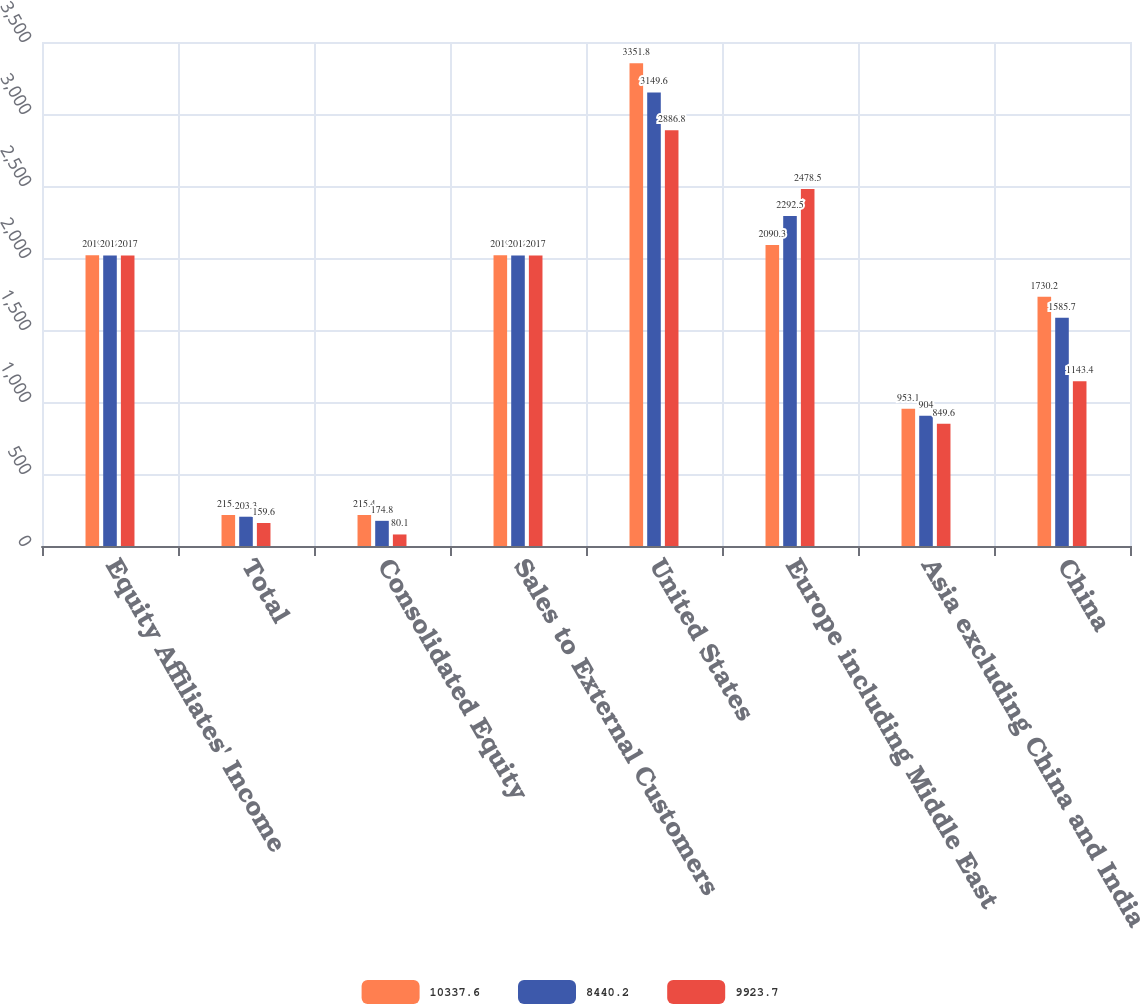Convert chart to OTSL. <chart><loc_0><loc_0><loc_500><loc_500><stacked_bar_chart><ecel><fcel>Equity Affiliates' Income<fcel>Total<fcel>Consolidated Equity<fcel>Sales to External Customers<fcel>United States<fcel>Europe including Middle East<fcel>Asia excluding China and India<fcel>China<nl><fcel>10337.6<fcel>2019<fcel>215.4<fcel>215.4<fcel>2019<fcel>3351.8<fcel>2090.3<fcel>953.1<fcel>1730.2<nl><fcel>8440.2<fcel>2018<fcel>203.3<fcel>174.8<fcel>2018<fcel>3149.6<fcel>2292.5<fcel>904<fcel>1585.7<nl><fcel>9923.7<fcel>2017<fcel>159.6<fcel>80.1<fcel>2017<fcel>2886.8<fcel>2478.5<fcel>849.6<fcel>1143.4<nl></chart> 